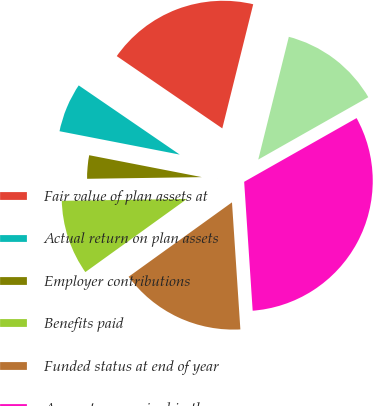Convert chart to OTSL. <chart><loc_0><loc_0><loc_500><loc_500><pie_chart><fcel>Fair value of plan assets at<fcel>Actual return on plan assets<fcel>Employer contributions<fcel>Benefits paid<fcel>Funded status at end of year<fcel>Amounts recognized in the<fcel>Accrued benefit<nl><fcel>19.33%<fcel>6.5%<fcel>3.29%<fcel>9.7%<fcel>16.12%<fcel>32.16%<fcel>12.91%<nl></chart> 